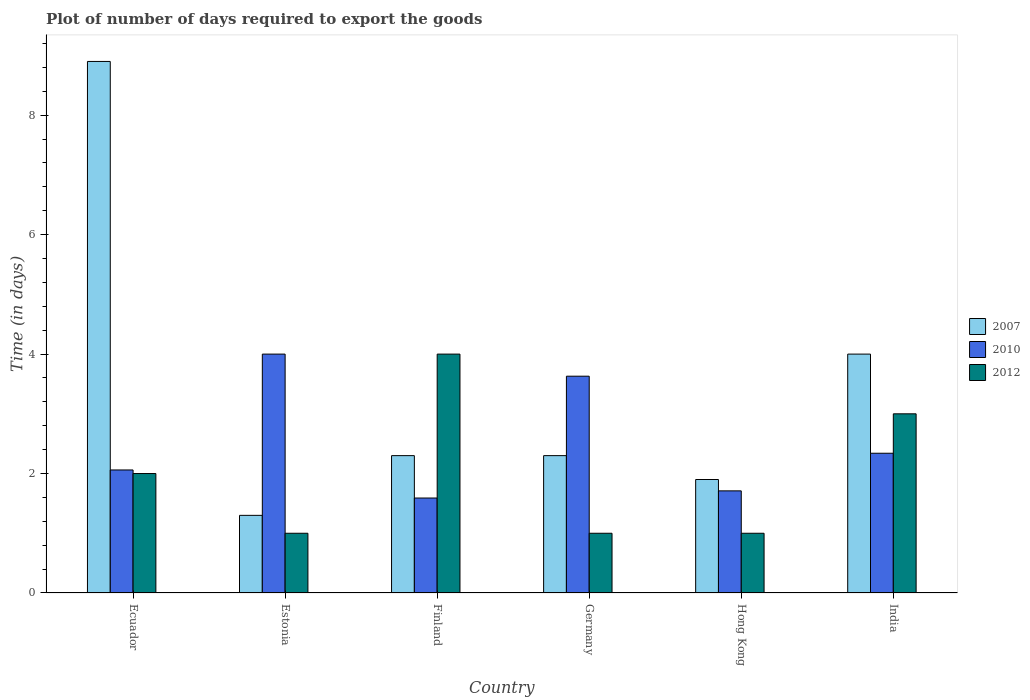How many different coloured bars are there?
Offer a very short reply. 3. How many groups of bars are there?
Your response must be concise. 6. How many bars are there on the 6th tick from the left?
Offer a terse response. 3. How many bars are there on the 1st tick from the right?
Your answer should be very brief. 3. Across all countries, what is the maximum time required to export goods in 2010?
Make the answer very short. 4. Across all countries, what is the minimum time required to export goods in 2007?
Give a very brief answer. 1.3. In which country was the time required to export goods in 2007 maximum?
Give a very brief answer. Ecuador. What is the difference between the time required to export goods in 2012 in Germany and that in Hong Kong?
Your answer should be compact. 0. What is the difference between the time required to export goods in 2007 in India and the time required to export goods in 2010 in Ecuador?
Ensure brevity in your answer.  1.94. What is the average time required to export goods in 2012 per country?
Offer a terse response. 2. What is the difference between the time required to export goods of/in 2012 and time required to export goods of/in 2010 in Hong Kong?
Your answer should be very brief. -0.71. What is the ratio of the time required to export goods in 2007 in Finland to that in India?
Your answer should be very brief. 0.57. What is the difference between the highest and the lowest time required to export goods in 2010?
Keep it short and to the point. 2.41. In how many countries, is the time required to export goods in 2012 greater than the average time required to export goods in 2012 taken over all countries?
Offer a terse response. 2. Is the sum of the time required to export goods in 2010 in Ecuador and Hong Kong greater than the maximum time required to export goods in 2012 across all countries?
Make the answer very short. No. What does the 1st bar from the left in Ecuador represents?
Offer a terse response. 2007. What does the 1st bar from the right in Hong Kong represents?
Give a very brief answer. 2012. Is it the case that in every country, the sum of the time required to export goods in 2012 and time required to export goods in 2007 is greater than the time required to export goods in 2010?
Your response must be concise. No. How many bars are there?
Offer a terse response. 18. Are all the bars in the graph horizontal?
Provide a short and direct response. No. What is the difference between two consecutive major ticks on the Y-axis?
Ensure brevity in your answer.  2. Does the graph contain any zero values?
Your answer should be compact. No. How many legend labels are there?
Offer a very short reply. 3. How are the legend labels stacked?
Keep it short and to the point. Vertical. What is the title of the graph?
Make the answer very short. Plot of number of days required to export the goods. Does "1975" appear as one of the legend labels in the graph?
Offer a very short reply. No. What is the label or title of the Y-axis?
Offer a terse response. Time (in days). What is the Time (in days) in 2010 in Ecuador?
Offer a terse response. 2.06. What is the Time (in days) of 2007 in Finland?
Offer a very short reply. 2.3. What is the Time (in days) of 2010 in Finland?
Keep it short and to the point. 1.59. What is the Time (in days) in 2010 in Germany?
Your answer should be very brief. 3.63. What is the Time (in days) of 2007 in Hong Kong?
Offer a terse response. 1.9. What is the Time (in days) of 2010 in Hong Kong?
Your answer should be very brief. 1.71. What is the Time (in days) of 2012 in Hong Kong?
Your answer should be compact. 1. What is the Time (in days) in 2007 in India?
Offer a very short reply. 4. What is the Time (in days) of 2010 in India?
Provide a short and direct response. 2.34. Across all countries, what is the maximum Time (in days) of 2007?
Offer a very short reply. 8.9. Across all countries, what is the maximum Time (in days) of 2010?
Offer a very short reply. 4. Across all countries, what is the maximum Time (in days) in 2012?
Offer a terse response. 4. Across all countries, what is the minimum Time (in days) of 2007?
Your answer should be very brief. 1.3. Across all countries, what is the minimum Time (in days) of 2010?
Provide a short and direct response. 1.59. Across all countries, what is the minimum Time (in days) of 2012?
Give a very brief answer. 1. What is the total Time (in days) in 2007 in the graph?
Your answer should be very brief. 20.7. What is the total Time (in days) in 2010 in the graph?
Your answer should be very brief. 15.33. What is the total Time (in days) in 2012 in the graph?
Give a very brief answer. 12. What is the difference between the Time (in days) in 2007 in Ecuador and that in Estonia?
Offer a very short reply. 7.6. What is the difference between the Time (in days) of 2010 in Ecuador and that in Estonia?
Provide a succinct answer. -1.94. What is the difference between the Time (in days) in 2007 in Ecuador and that in Finland?
Ensure brevity in your answer.  6.6. What is the difference between the Time (in days) in 2010 in Ecuador and that in Finland?
Your answer should be very brief. 0.47. What is the difference between the Time (in days) in 2012 in Ecuador and that in Finland?
Ensure brevity in your answer.  -2. What is the difference between the Time (in days) of 2010 in Ecuador and that in Germany?
Your answer should be compact. -1.57. What is the difference between the Time (in days) in 2010 in Ecuador and that in Hong Kong?
Ensure brevity in your answer.  0.35. What is the difference between the Time (in days) in 2012 in Ecuador and that in Hong Kong?
Offer a terse response. 1. What is the difference between the Time (in days) in 2010 in Ecuador and that in India?
Offer a very short reply. -0.28. What is the difference between the Time (in days) of 2012 in Ecuador and that in India?
Your answer should be compact. -1. What is the difference between the Time (in days) in 2007 in Estonia and that in Finland?
Your answer should be compact. -1. What is the difference between the Time (in days) in 2010 in Estonia and that in Finland?
Your answer should be compact. 2.41. What is the difference between the Time (in days) of 2012 in Estonia and that in Finland?
Your response must be concise. -3. What is the difference between the Time (in days) of 2007 in Estonia and that in Germany?
Ensure brevity in your answer.  -1. What is the difference between the Time (in days) in 2010 in Estonia and that in Germany?
Your answer should be very brief. 0.37. What is the difference between the Time (in days) in 2012 in Estonia and that in Germany?
Keep it short and to the point. 0. What is the difference between the Time (in days) of 2007 in Estonia and that in Hong Kong?
Your answer should be compact. -0.6. What is the difference between the Time (in days) in 2010 in Estonia and that in Hong Kong?
Keep it short and to the point. 2.29. What is the difference between the Time (in days) of 2007 in Estonia and that in India?
Offer a terse response. -2.7. What is the difference between the Time (in days) of 2010 in Estonia and that in India?
Your answer should be very brief. 1.66. What is the difference between the Time (in days) in 2012 in Estonia and that in India?
Make the answer very short. -2. What is the difference between the Time (in days) of 2010 in Finland and that in Germany?
Keep it short and to the point. -2.04. What is the difference between the Time (in days) of 2010 in Finland and that in Hong Kong?
Your answer should be very brief. -0.12. What is the difference between the Time (in days) in 2010 in Finland and that in India?
Your answer should be compact. -0.75. What is the difference between the Time (in days) in 2007 in Germany and that in Hong Kong?
Offer a very short reply. 0.4. What is the difference between the Time (in days) in 2010 in Germany and that in Hong Kong?
Ensure brevity in your answer.  1.92. What is the difference between the Time (in days) of 2007 in Germany and that in India?
Your answer should be compact. -1.7. What is the difference between the Time (in days) in 2010 in Germany and that in India?
Offer a very short reply. 1.29. What is the difference between the Time (in days) of 2012 in Germany and that in India?
Provide a succinct answer. -2. What is the difference between the Time (in days) of 2010 in Hong Kong and that in India?
Provide a short and direct response. -0.63. What is the difference between the Time (in days) in 2012 in Hong Kong and that in India?
Provide a succinct answer. -2. What is the difference between the Time (in days) in 2010 in Ecuador and the Time (in days) in 2012 in Estonia?
Provide a short and direct response. 1.06. What is the difference between the Time (in days) of 2007 in Ecuador and the Time (in days) of 2010 in Finland?
Ensure brevity in your answer.  7.31. What is the difference between the Time (in days) of 2010 in Ecuador and the Time (in days) of 2012 in Finland?
Give a very brief answer. -1.94. What is the difference between the Time (in days) in 2007 in Ecuador and the Time (in days) in 2010 in Germany?
Your answer should be compact. 5.27. What is the difference between the Time (in days) in 2007 in Ecuador and the Time (in days) in 2012 in Germany?
Offer a terse response. 7.9. What is the difference between the Time (in days) of 2010 in Ecuador and the Time (in days) of 2012 in Germany?
Provide a short and direct response. 1.06. What is the difference between the Time (in days) of 2007 in Ecuador and the Time (in days) of 2010 in Hong Kong?
Keep it short and to the point. 7.19. What is the difference between the Time (in days) in 2010 in Ecuador and the Time (in days) in 2012 in Hong Kong?
Offer a terse response. 1.06. What is the difference between the Time (in days) in 2007 in Ecuador and the Time (in days) in 2010 in India?
Offer a terse response. 6.56. What is the difference between the Time (in days) of 2007 in Ecuador and the Time (in days) of 2012 in India?
Make the answer very short. 5.9. What is the difference between the Time (in days) of 2010 in Ecuador and the Time (in days) of 2012 in India?
Ensure brevity in your answer.  -0.94. What is the difference between the Time (in days) of 2007 in Estonia and the Time (in days) of 2010 in Finland?
Provide a short and direct response. -0.29. What is the difference between the Time (in days) in 2007 in Estonia and the Time (in days) in 2010 in Germany?
Your response must be concise. -2.33. What is the difference between the Time (in days) in 2010 in Estonia and the Time (in days) in 2012 in Germany?
Your answer should be compact. 3. What is the difference between the Time (in days) of 2007 in Estonia and the Time (in days) of 2010 in Hong Kong?
Offer a terse response. -0.41. What is the difference between the Time (in days) of 2007 in Estonia and the Time (in days) of 2010 in India?
Your response must be concise. -1.04. What is the difference between the Time (in days) in 2007 in Estonia and the Time (in days) in 2012 in India?
Offer a terse response. -1.7. What is the difference between the Time (in days) in 2007 in Finland and the Time (in days) in 2010 in Germany?
Your answer should be compact. -1.33. What is the difference between the Time (in days) of 2010 in Finland and the Time (in days) of 2012 in Germany?
Your answer should be compact. 0.59. What is the difference between the Time (in days) of 2007 in Finland and the Time (in days) of 2010 in Hong Kong?
Provide a short and direct response. 0.59. What is the difference between the Time (in days) in 2010 in Finland and the Time (in days) in 2012 in Hong Kong?
Give a very brief answer. 0.59. What is the difference between the Time (in days) of 2007 in Finland and the Time (in days) of 2010 in India?
Offer a very short reply. -0.04. What is the difference between the Time (in days) in 2010 in Finland and the Time (in days) in 2012 in India?
Offer a terse response. -1.41. What is the difference between the Time (in days) of 2007 in Germany and the Time (in days) of 2010 in Hong Kong?
Provide a short and direct response. 0.59. What is the difference between the Time (in days) in 2007 in Germany and the Time (in days) in 2012 in Hong Kong?
Give a very brief answer. 1.3. What is the difference between the Time (in days) of 2010 in Germany and the Time (in days) of 2012 in Hong Kong?
Your answer should be compact. 2.63. What is the difference between the Time (in days) in 2007 in Germany and the Time (in days) in 2010 in India?
Ensure brevity in your answer.  -0.04. What is the difference between the Time (in days) in 2010 in Germany and the Time (in days) in 2012 in India?
Keep it short and to the point. 0.63. What is the difference between the Time (in days) of 2007 in Hong Kong and the Time (in days) of 2010 in India?
Ensure brevity in your answer.  -0.44. What is the difference between the Time (in days) in 2010 in Hong Kong and the Time (in days) in 2012 in India?
Your answer should be very brief. -1.29. What is the average Time (in days) in 2007 per country?
Provide a short and direct response. 3.45. What is the average Time (in days) in 2010 per country?
Your answer should be very brief. 2.56. What is the difference between the Time (in days) of 2007 and Time (in days) of 2010 in Ecuador?
Your answer should be very brief. 6.84. What is the difference between the Time (in days) in 2007 and Time (in days) in 2010 in Finland?
Offer a terse response. 0.71. What is the difference between the Time (in days) in 2007 and Time (in days) in 2012 in Finland?
Offer a very short reply. -1.7. What is the difference between the Time (in days) in 2010 and Time (in days) in 2012 in Finland?
Provide a short and direct response. -2.41. What is the difference between the Time (in days) of 2007 and Time (in days) of 2010 in Germany?
Offer a terse response. -1.33. What is the difference between the Time (in days) in 2007 and Time (in days) in 2012 in Germany?
Offer a terse response. 1.3. What is the difference between the Time (in days) in 2010 and Time (in days) in 2012 in Germany?
Offer a terse response. 2.63. What is the difference between the Time (in days) of 2007 and Time (in days) of 2010 in Hong Kong?
Your answer should be very brief. 0.19. What is the difference between the Time (in days) of 2007 and Time (in days) of 2012 in Hong Kong?
Ensure brevity in your answer.  0.9. What is the difference between the Time (in days) of 2010 and Time (in days) of 2012 in Hong Kong?
Ensure brevity in your answer.  0.71. What is the difference between the Time (in days) in 2007 and Time (in days) in 2010 in India?
Provide a succinct answer. 1.66. What is the difference between the Time (in days) in 2007 and Time (in days) in 2012 in India?
Your answer should be very brief. 1. What is the difference between the Time (in days) in 2010 and Time (in days) in 2012 in India?
Provide a short and direct response. -0.66. What is the ratio of the Time (in days) of 2007 in Ecuador to that in Estonia?
Give a very brief answer. 6.85. What is the ratio of the Time (in days) of 2010 in Ecuador to that in Estonia?
Your response must be concise. 0.52. What is the ratio of the Time (in days) of 2007 in Ecuador to that in Finland?
Provide a short and direct response. 3.87. What is the ratio of the Time (in days) of 2010 in Ecuador to that in Finland?
Your answer should be compact. 1.3. What is the ratio of the Time (in days) in 2012 in Ecuador to that in Finland?
Make the answer very short. 0.5. What is the ratio of the Time (in days) of 2007 in Ecuador to that in Germany?
Provide a succinct answer. 3.87. What is the ratio of the Time (in days) in 2010 in Ecuador to that in Germany?
Offer a terse response. 0.57. What is the ratio of the Time (in days) in 2007 in Ecuador to that in Hong Kong?
Your response must be concise. 4.68. What is the ratio of the Time (in days) of 2010 in Ecuador to that in Hong Kong?
Your answer should be compact. 1.2. What is the ratio of the Time (in days) in 2012 in Ecuador to that in Hong Kong?
Your answer should be very brief. 2. What is the ratio of the Time (in days) of 2007 in Ecuador to that in India?
Ensure brevity in your answer.  2.23. What is the ratio of the Time (in days) of 2010 in Ecuador to that in India?
Offer a terse response. 0.88. What is the ratio of the Time (in days) of 2012 in Ecuador to that in India?
Provide a short and direct response. 0.67. What is the ratio of the Time (in days) of 2007 in Estonia to that in Finland?
Provide a short and direct response. 0.57. What is the ratio of the Time (in days) in 2010 in Estonia to that in Finland?
Make the answer very short. 2.52. What is the ratio of the Time (in days) of 2007 in Estonia to that in Germany?
Your response must be concise. 0.57. What is the ratio of the Time (in days) in 2010 in Estonia to that in Germany?
Offer a very short reply. 1.1. What is the ratio of the Time (in days) of 2007 in Estonia to that in Hong Kong?
Ensure brevity in your answer.  0.68. What is the ratio of the Time (in days) of 2010 in Estonia to that in Hong Kong?
Offer a very short reply. 2.34. What is the ratio of the Time (in days) of 2012 in Estonia to that in Hong Kong?
Make the answer very short. 1. What is the ratio of the Time (in days) in 2007 in Estonia to that in India?
Keep it short and to the point. 0.33. What is the ratio of the Time (in days) of 2010 in Estonia to that in India?
Your response must be concise. 1.71. What is the ratio of the Time (in days) in 2007 in Finland to that in Germany?
Keep it short and to the point. 1. What is the ratio of the Time (in days) in 2010 in Finland to that in Germany?
Ensure brevity in your answer.  0.44. What is the ratio of the Time (in days) in 2007 in Finland to that in Hong Kong?
Offer a terse response. 1.21. What is the ratio of the Time (in days) of 2010 in Finland to that in Hong Kong?
Your response must be concise. 0.93. What is the ratio of the Time (in days) in 2012 in Finland to that in Hong Kong?
Offer a terse response. 4. What is the ratio of the Time (in days) of 2007 in Finland to that in India?
Provide a succinct answer. 0.57. What is the ratio of the Time (in days) in 2010 in Finland to that in India?
Give a very brief answer. 0.68. What is the ratio of the Time (in days) of 2012 in Finland to that in India?
Your answer should be very brief. 1.33. What is the ratio of the Time (in days) of 2007 in Germany to that in Hong Kong?
Provide a succinct answer. 1.21. What is the ratio of the Time (in days) in 2010 in Germany to that in Hong Kong?
Offer a terse response. 2.12. What is the ratio of the Time (in days) of 2012 in Germany to that in Hong Kong?
Offer a very short reply. 1. What is the ratio of the Time (in days) of 2007 in Germany to that in India?
Offer a very short reply. 0.57. What is the ratio of the Time (in days) in 2010 in Germany to that in India?
Offer a terse response. 1.55. What is the ratio of the Time (in days) of 2007 in Hong Kong to that in India?
Offer a terse response. 0.47. What is the ratio of the Time (in days) in 2010 in Hong Kong to that in India?
Your response must be concise. 0.73. What is the ratio of the Time (in days) of 2012 in Hong Kong to that in India?
Keep it short and to the point. 0.33. What is the difference between the highest and the second highest Time (in days) of 2010?
Your answer should be compact. 0.37. What is the difference between the highest and the second highest Time (in days) of 2012?
Your answer should be compact. 1. What is the difference between the highest and the lowest Time (in days) in 2007?
Your response must be concise. 7.6. What is the difference between the highest and the lowest Time (in days) in 2010?
Your response must be concise. 2.41. 